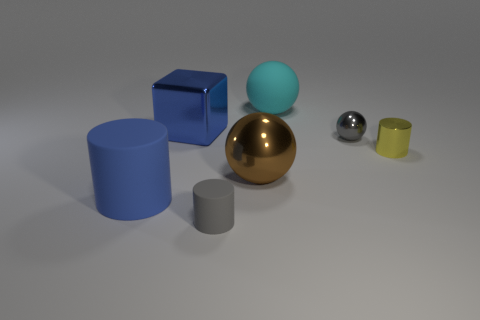Subtract all tiny cylinders. How many cylinders are left? 1 Add 3 small gray metal spheres. How many objects exist? 10 Subtract all balls. How many objects are left? 4 Subtract 2 cylinders. How many cylinders are left? 1 Subtract all brown balls. How many balls are left? 2 Subtract all yellow metal things. Subtract all small yellow objects. How many objects are left? 5 Add 4 shiny spheres. How many shiny spheres are left? 6 Add 5 cyan matte objects. How many cyan matte objects exist? 6 Subtract 0 yellow blocks. How many objects are left? 7 Subtract all yellow spheres. Subtract all yellow cylinders. How many spheres are left? 3 